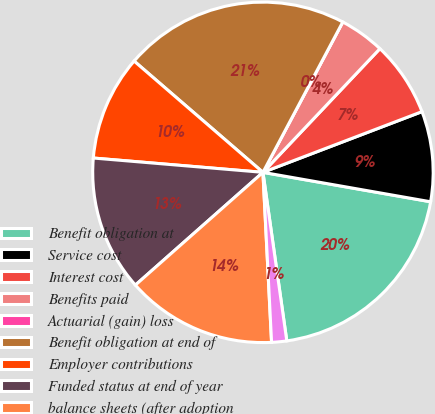Convert chart. <chart><loc_0><loc_0><loc_500><loc_500><pie_chart><fcel>Benefit obligation at<fcel>Service cost<fcel>Interest cost<fcel>Benefits paid<fcel>Actuarial (gain) loss<fcel>Benefit obligation at end of<fcel>Employer contributions<fcel>Funded status at end of year<fcel>balance sheets (after adoption<fcel>Current liabilities<nl><fcel>20.0%<fcel>8.57%<fcel>7.14%<fcel>4.29%<fcel>0.0%<fcel>21.43%<fcel>10.0%<fcel>12.86%<fcel>14.29%<fcel>1.43%<nl></chart> 